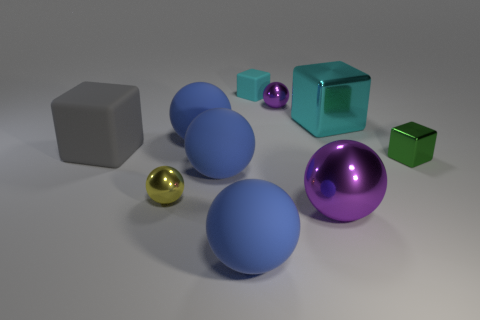Is the material of the large purple object the same as the large gray cube?
Provide a short and direct response. No. Is there another small shiny object that has the same shape as the yellow shiny thing?
Your response must be concise. Yes. There is a large metal thing that is the same color as the tiny matte object; what is its shape?
Provide a succinct answer. Cube. There is a block that is behind the purple thing on the left side of the large purple metal sphere; is there a matte object in front of it?
Offer a very short reply. Yes. What is the shape of the green object that is the same size as the cyan matte thing?
Offer a terse response. Cube. What color is the other metallic thing that is the same shape as the green object?
Give a very brief answer. Cyan. What number of things are either cyan cubes or large purple metal balls?
Offer a very short reply. 3. Do the tiny object that is right of the large purple object and the cyan thing that is in front of the small cyan matte thing have the same shape?
Make the answer very short. Yes. There is a blue thing that is behind the green shiny object; what is its shape?
Ensure brevity in your answer.  Sphere. Are there the same number of large metal spheres that are behind the small green metallic thing and matte blocks in front of the large cyan cube?
Ensure brevity in your answer.  No. 